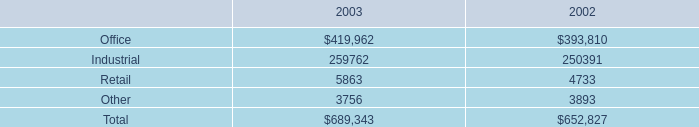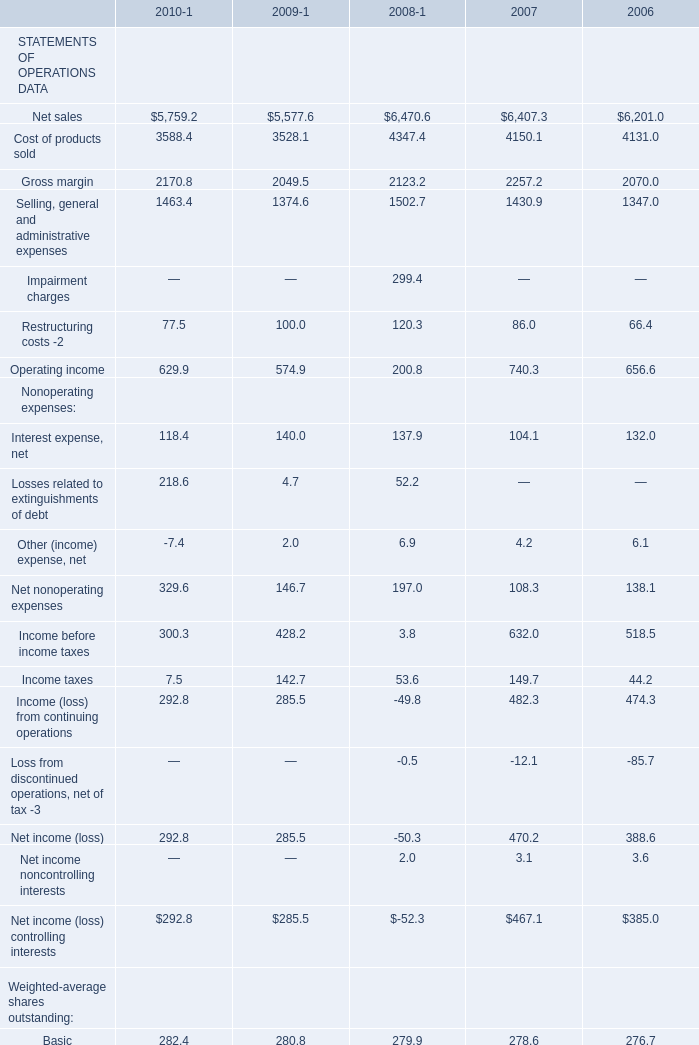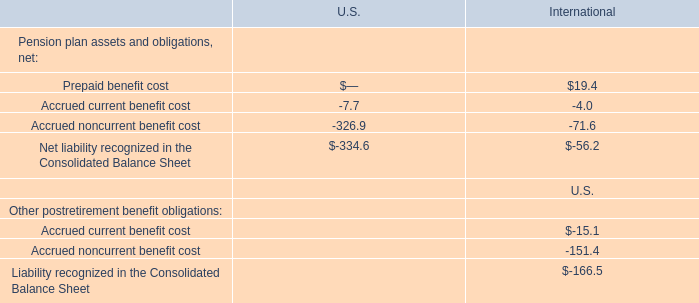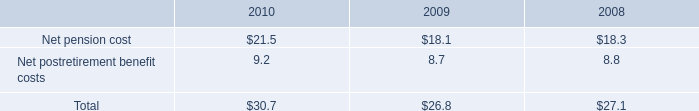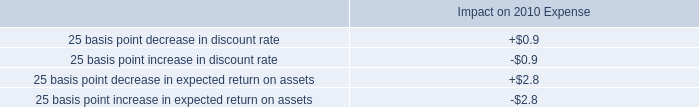what is the percent change in rental income from continuing operations from 2002 to 2003? 
Computations: (((689343 - 652827) / 652827) * 100)
Answer: 5.59352. 